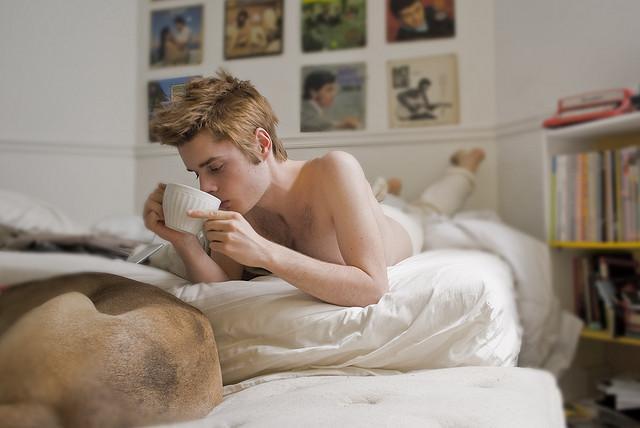How many people are there?
Give a very brief answer. 2. 